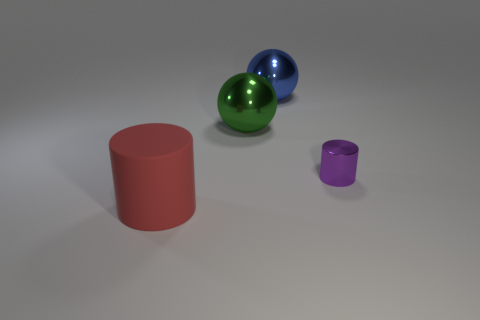There is a green object that is the same size as the red object; what material is it?
Your answer should be very brief. Metal. Is the small cylinder made of the same material as the blue object?
Ensure brevity in your answer.  Yes. There is a thing that is in front of the large green metallic ball and to the right of the big cylinder; what color is it?
Give a very brief answer. Purple. What shape is the blue object that is the same size as the green ball?
Ensure brevity in your answer.  Sphere. What number of other objects are the same color as the tiny object?
Provide a succinct answer. 0. How many other things are the same material as the red cylinder?
Make the answer very short. 0. There is a blue metal sphere; is it the same size as the cylinder that is on the right side of the red matte object?
Provide a short and direct response. No. What is the color of the big cylinder?
Make the answer very short. Red. The metal thing that is in front of the metallic sphere that is left of the big object that is behind the large green object is what shape?
Ensure brevity in your answer.  Cylinder. What material is the cylinder to the left of the cylinder behind the big cylinder?
Keep it short and to the point. Rubber. 